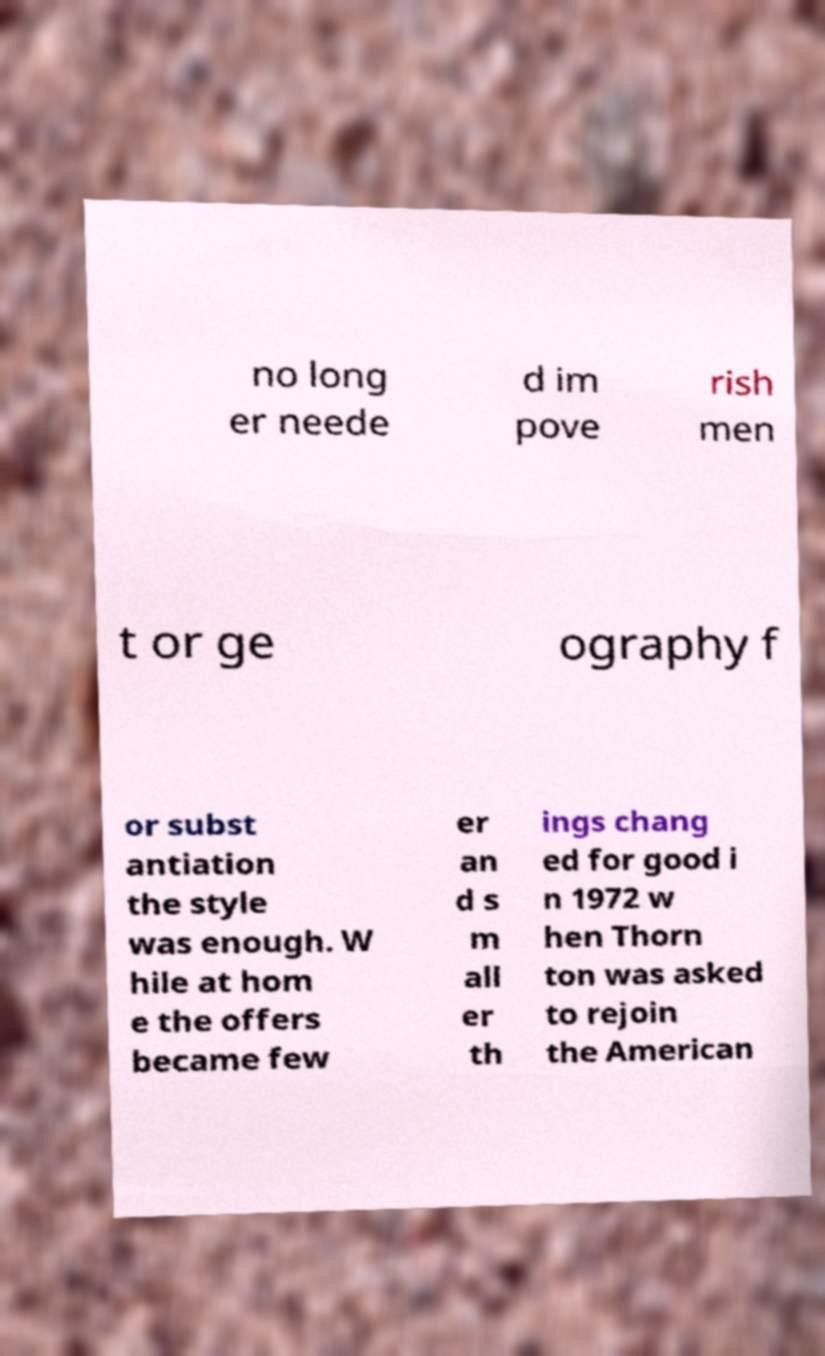What messages or text are displayed in this image? I need them in a readable, typed format. no long er neede d im pove rish men t or ge ography f or subst antiation the style was enough. W hile at hom e the offers became few er an d s m all er th ings chang ed for good i n 1972 w hen Thorn ton was asked to rejoin the American 